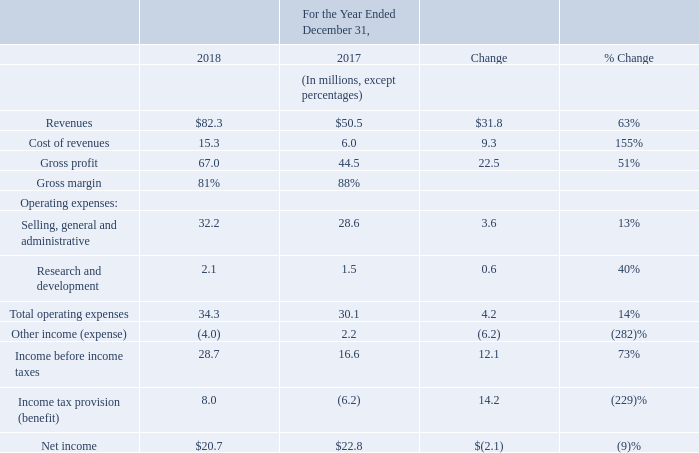Year ended December 31, 2018 compared with the year ended December 31, 2017:
Revenue in 2018 is derived from multiple license agreements that we entered into with third-parties following negotiations pursuant to our patent licensing and enforcement program. The revenue increase is primarily due to licensing revenues, as further described in "Item 1. Business" - "Licensing and Enforcement - Current Activities, Post 2013".
Cost of revenues includes contingent legal fees directly associated with our licensing and enforcement programs. Cost of revenues increased largely in proportion to increase in revenues.
Selling, general and administrative expenses ("SG&A") consisted primarily of legal fees incurred in operations and employee headcount related expenses. These comprise approximately 74% of total SG&A expense. Litigation expenses increased $4.2 million to $16.5 million in 2018 compared to 2017 and are primarily due to the timing of various outstanding litigation actions. See "Item 3. Legal Proceedings". Employee headcount related expenses increased $1.8 million to $7.2 million in 2018 compared to 2017, and is primarily due to incentive bonuses earned during the year. The balance of SG&A expenses include consulting, other professional services, facilities and other administrative fees and expenses.
Research and Development expenses ("R&D") are primarily from our Finjan Mobile security business and increased by $0.6 million to $2.1 million in 2018 compared to 2017, as we continue to position this business for future growth.
Other income (expense) is primarily due to changes in the fair value of the warrant liability of $3.4 million in 2018 versus a benefit of $2.2 million in 2017, and interest expense of $0.6 million in 2018, net.
We recognized an income tax expense of $8.1 million on pre-tax income of $28.7 million in 2018 as compared to a benefit from the reduction in the valuation allowance of $6.2 million in 2017.
What are the respective increase in R&D expenses between 2017 and 2018, as well as the R&D expenses in 2018? $0.6 million, $2.1 million. What are the respective fair value of the warrant liability and interest expense in 2018? $3.4 million, $0.6 million. What are the respective income tax expense and pre-tax income in 2018? $8.1 million, $28.7 million. What is the value of pre-tax income as a percentage of revenues in 2018?
Answer scale should be: percent. 28.7/82.3
Answer: 34.87. What is the value of the warrant liability fair value as a percentage of the cost of revenues in 2018?
Answer scale should be: percent. 3.4/15.3
Answer: 22.22. What is the value of R&D expenses as a percentage of the cost of revenues in 2018?
Answer scale should be: percent. 2.1/15.3 
Answer: 13.73. 